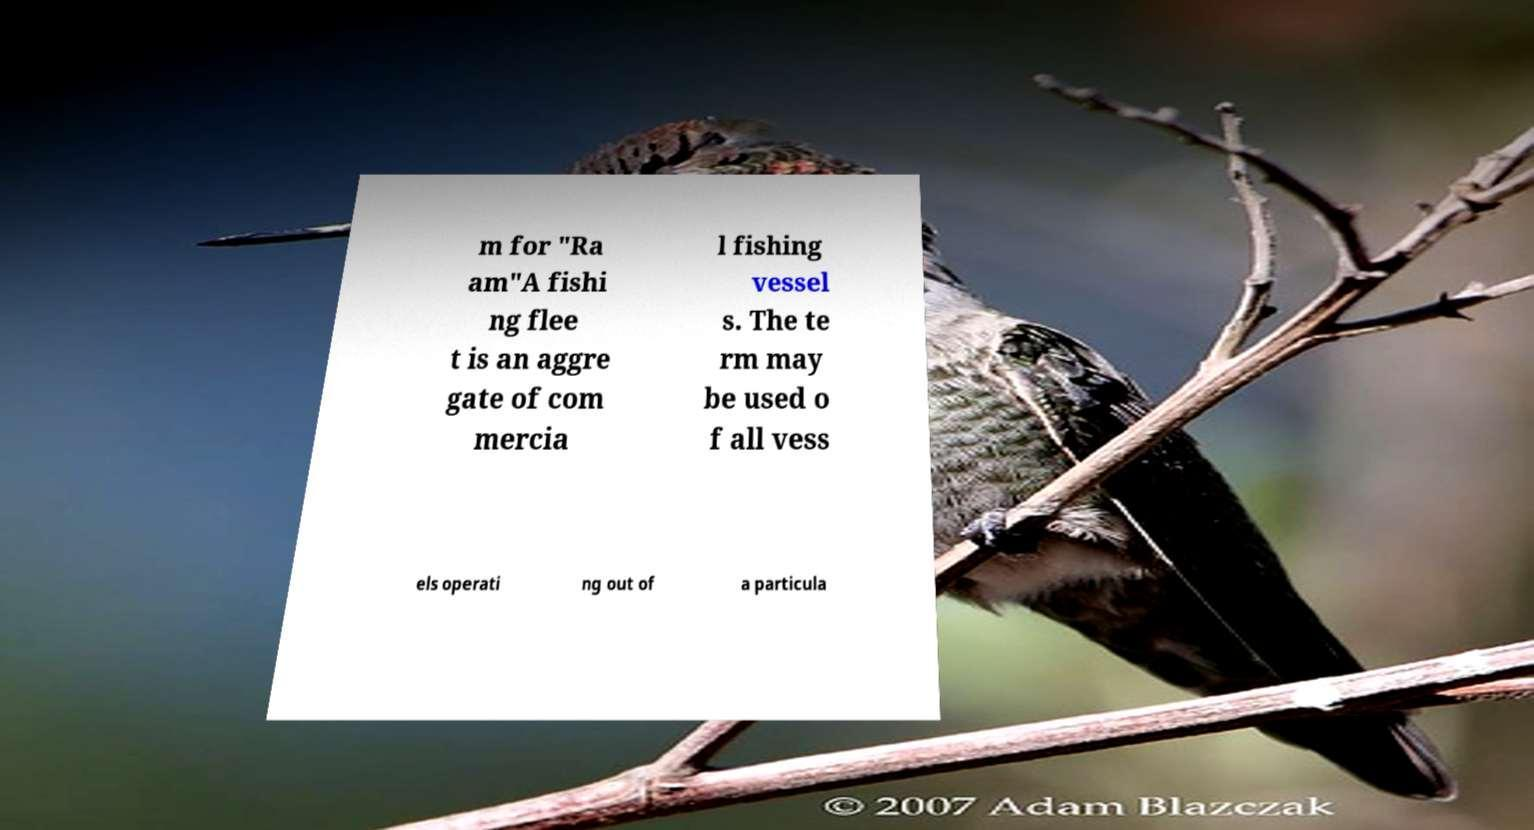Can you read and provide the text displayed in the image?This photo seems to have some interesting text. Can you extract and type it out for me? m for "Ra am"A fishi ng flee t is an aggre gate of com mercia l fishing vessel s. The te rm may be used o f all vess els operati ng out of a particula 